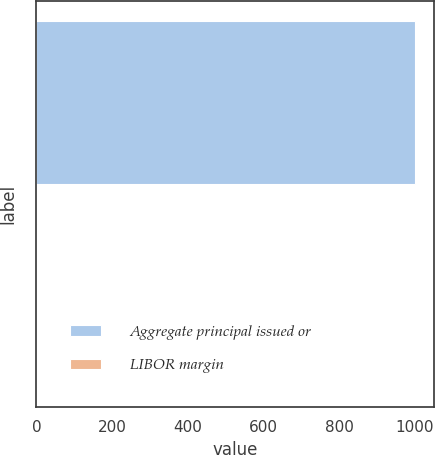<chart> <loc_0><loc_0><loc_500><loc_500><bar_chart><fcel>Aggregate principal issued or<fcel>LIBOR margin<nl><fcel>1000<fcel>2<nl></chart> 